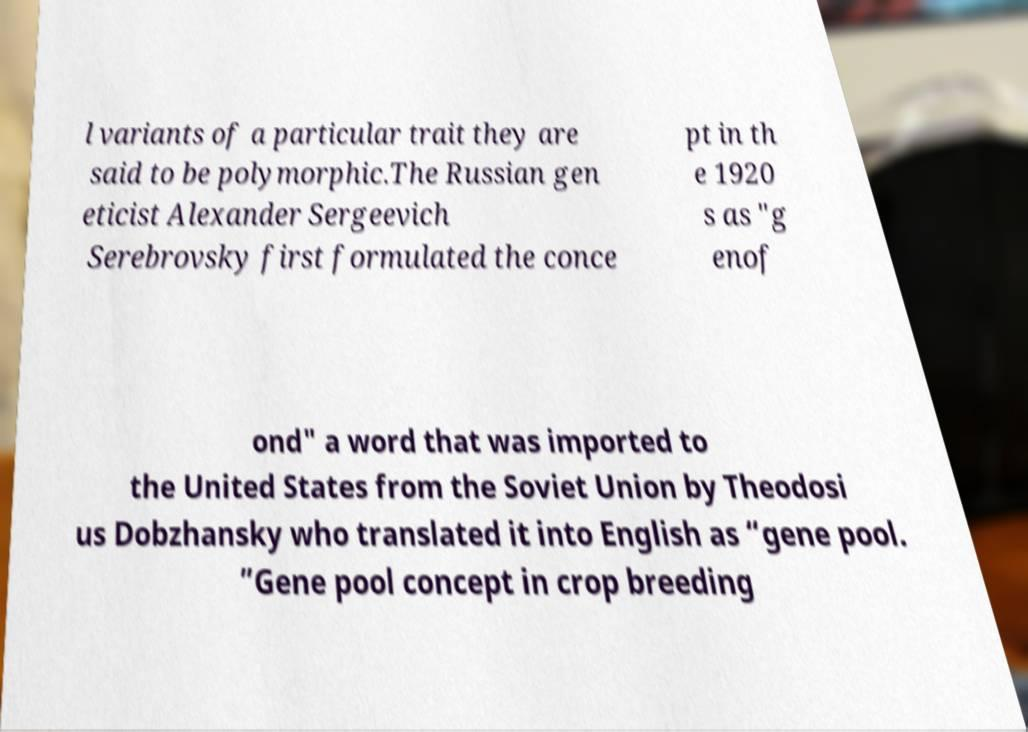Could you assist in decoding the text presented in this image and type it out clearly? l variants of a particular trait they are said to be polymorphic.The Russian gen eticist Alexander Sergeevich Serebrovsky first formulated the conce pt in th e 1920 s as "g enof ond" a word that was imported to the United States from the Soviet Union by Theodosi us Dobzhansky who translated it into English as “gene pool. ”Gene pool concept in crop breeding 